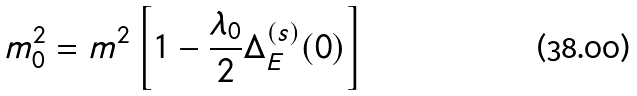<formula> <loc_0><loc_0><loc_500><loc_500>m _ { 0 } ^ { 2 } = m ^ { 2 } \left [ 1 - \frac { \lambda _ { 0 } } { 2 } \Delta _ { E } ^ { ( s ) } ( 0 ) \right ]</formula> 